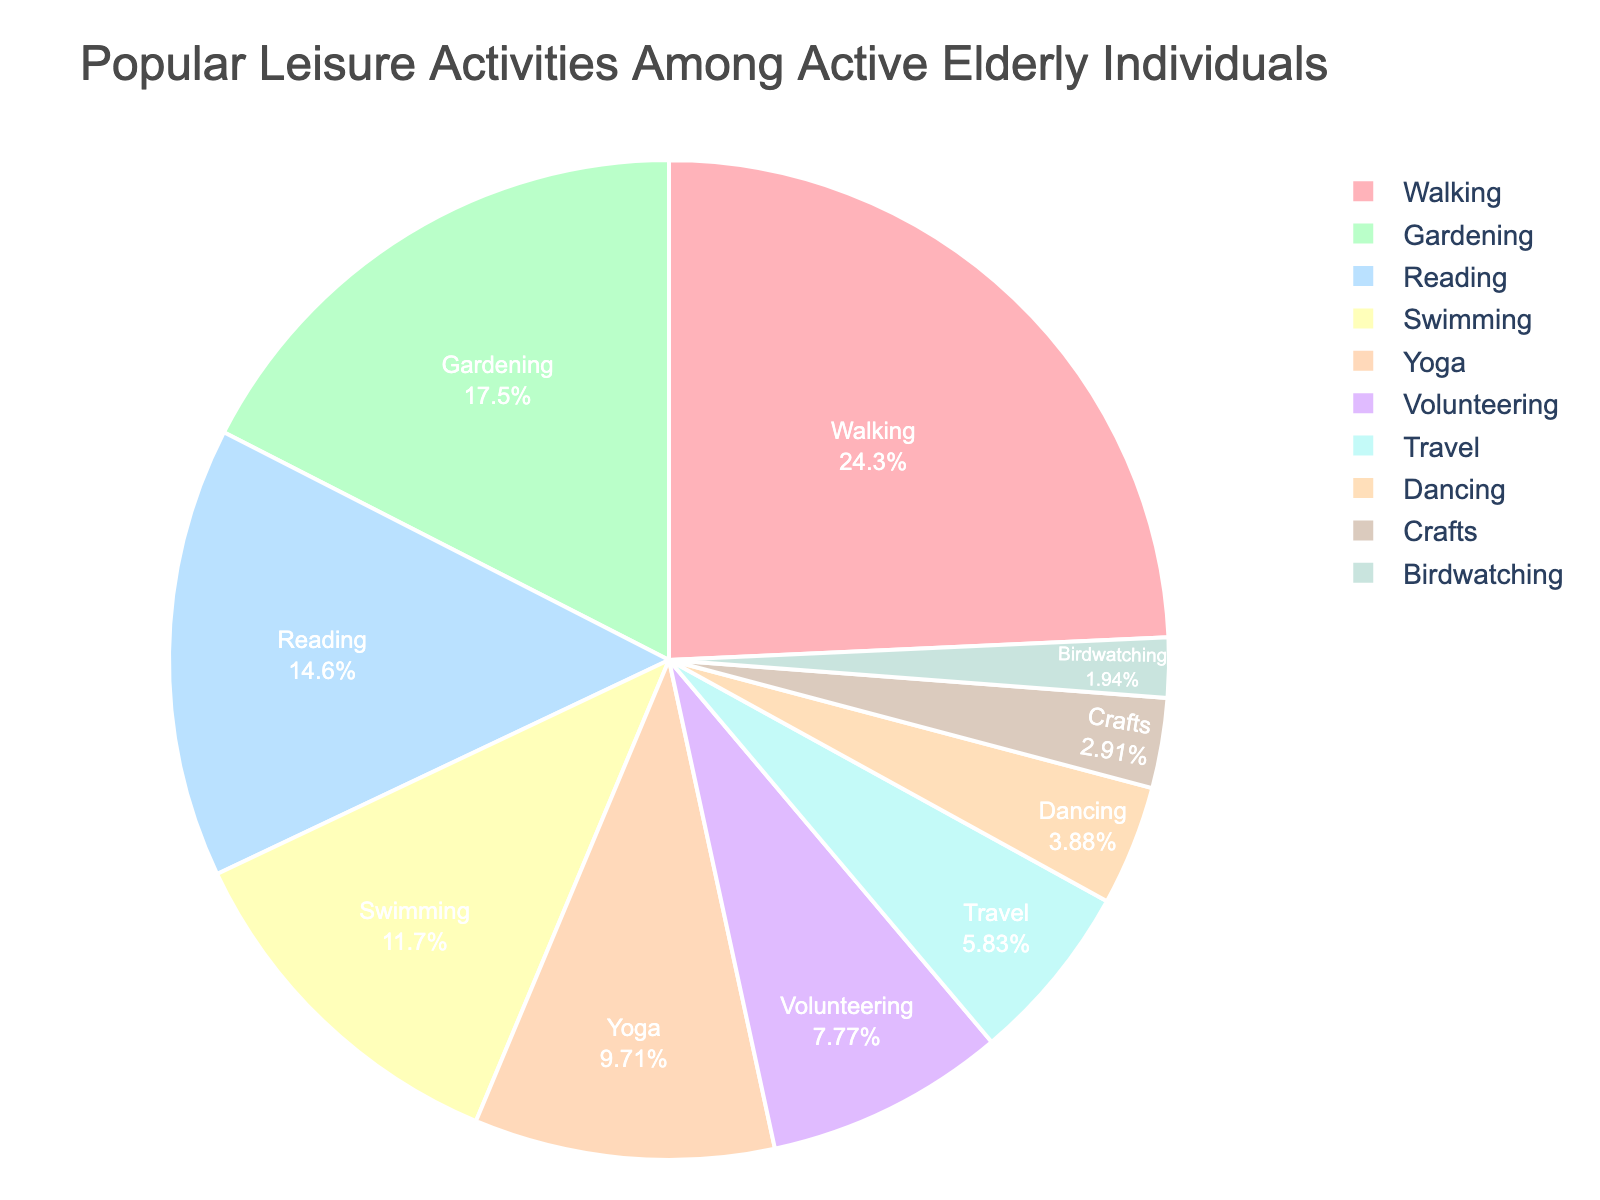What is the most popular leisure activity among active elderly individuals? The pie chart shows that the activity with the largest slice is Walking, comprising 25% of the total pie. Therefore, Walking is the most popular activity.
Answer: Walking How much more popular is Walking compared to Gardening? To find out how much more popular Walking is compared to Gardening, subtract the percentage for Gardening from that for Walking: 25% - 18% = 7%.
Answer: 7% What percentage of activities is accounted for by Reading, Yoga, and Birdwatching combined? Sum the percentages for Reading, Yoga, and Birdwatching: 15% (Reading) + 10% (Yoga) + 2% (Birdwatching) = 27%.
Answer: 27% Are there more elderly individuals that prefer Swimming or Volunteering? According to the pie chart, Swimming is preferred by 12% while Volunteering is preferred by 8%. Since 12% is greater than 8%, more elderly individuals prefer Swimming.
Answer: Swimming Which activity represents a smaller portion of the pie chart, Travel or Dancing? By comparing the percentages, Travel has 6% and Dancing has 4%. Since 4% is smaller than 6%, Dancing represents a smaller portion of the pie chart.
Answer: Dancing What is the total percentage of elderly individuals involved in Travel, Dancing, and Crafts? Sum the percentages for Travel, Dancing, and Crafts: 6% (Travel) + 4% (Dancing) + 3% (Crafts) = 13%.
Answer: 13% Which activities each account for less than 5% of the pie chart? By examining the pie chart, the activities that account for less than 5% are Dancing (4%), Crafts (3%), and Birdwatching (2%).
Answer: Dancing, Crafts, Birdwatching How does the popularity of Yoga compare to Swimming? The pie chart shows Yoga has a percentage of 10%, whereas Swimming has a percentage of 12%. Therefore, Yoga is less popular than Swimming.
Answer: less popular What is the combined percentage of all activities that make up more than 10%? Identify and sum the percentages for activities that make up more than 10%: 25% (Walking) + 18% (Gardening) + 15% (Reading) + 12% (Swimming) = 70%.
Answer: 70% If you were to remove the percentages for Volunteering and Birdwatching, how would the combined percentage for all other activities change? First, sum the total percentage of all activities: 100%. Then subtract the total percentage of Volunteering and Birdwatching: 100% - (8% + 2%) = 90%. The new total percentage for all other activities combined would be 90%.
Answer: 90% 